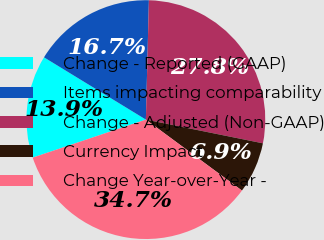Convert chart to OTSL. <chart><loc_0><loc_0><loc_500><loc_500><pie_chart><fcel>Change - Reported (GAAP)<fcel>Items impacting comparability<fcel>Change - Adjusted (Non-GAAP)<fcel>Currency Impact<fcel>Change Year-over-Year -<nl><fcel>13.89%<fcel>16.67%<fcel>27.78%<fcel>6.94%<fcel>34.72%<nl></chart> 